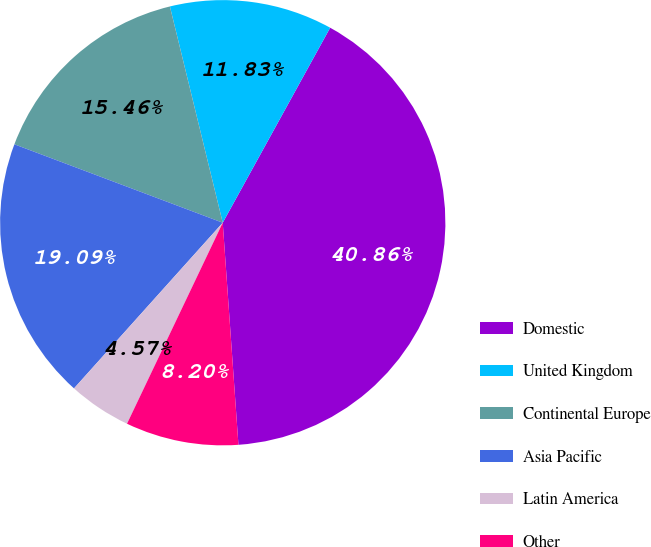Convert chart to OTSL. <chart><loc_0><loc_0><loc_500><loc_500><pie_chart><fcel>Domestic<fcel>United Kingdom<fcel>Continental Europe<fcel>Asia Pacific<fcel>Latin America<fcel>Other<nl><fcel>40.87%<fcel>11.83%<fcel>15.46%<fcel>19.09%<fcel>4.57%<fcel>8.2%<nl></chart> 